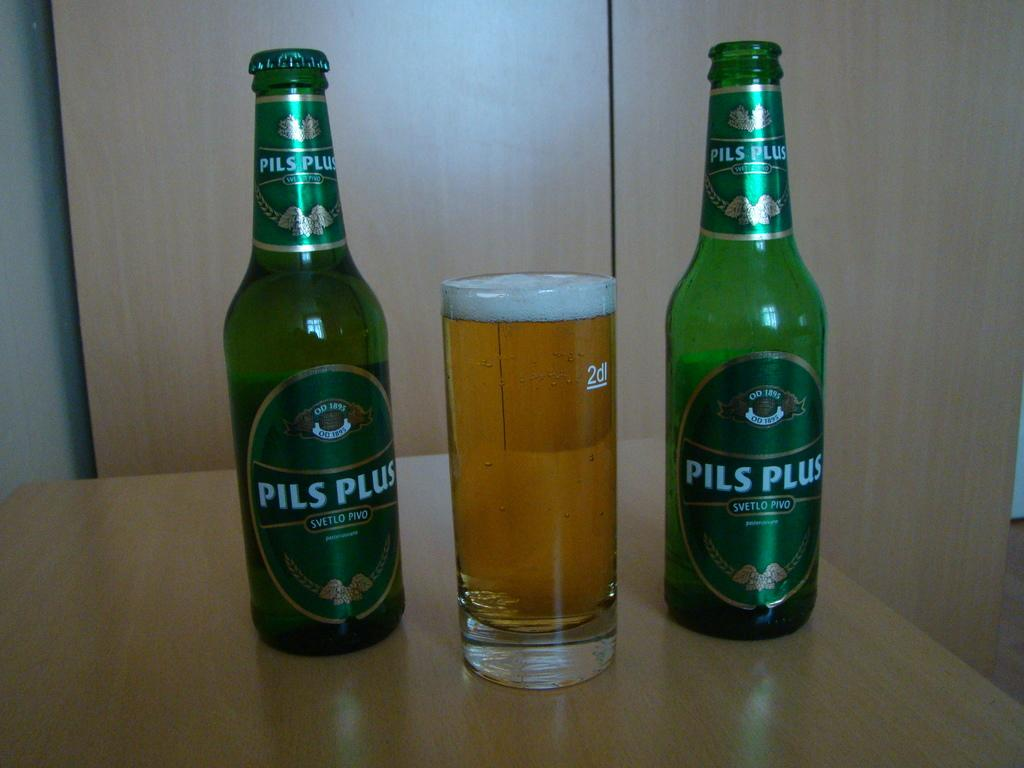Provide a one-sentence caption for the provided image. Two Pils Plus bottles, one is opened, and a glass of beer in the middle. 